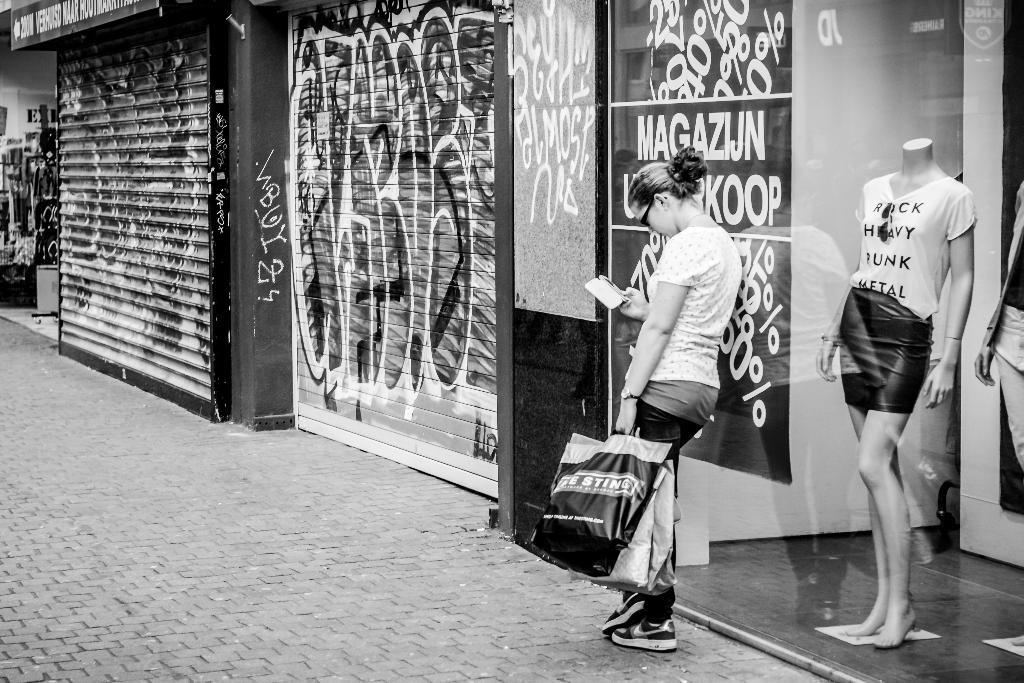What is the person in the image doing? The person is standing in the image and holding a bag and a mobile. What might the person be carrying in the bag? It is not clear what the person is carrying in the bag, but it could be personal belongings or items purchased from the stores. What can be seen in the background of the image? There are stores visible in the background, as well as a mannequin. What is the color scheme of the image? The image is in black and white. What type of development is taking place in the background of the image? There is no development project visible in the image; it only shows a person standing with a bag and a mobile, stores in the background, and a mannequin. What key is the person using to unlock the stores in the image? There is no key visible in the image, and the person is not shown unlocking any stores. 